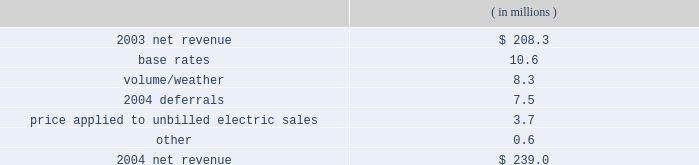Entergy new orleans , inc .
Management's financial discussion and analysis results of operations net income ( loss ) 2004 compared to 2003 net income increased $ 20.2 million primarily due to higher net revenue .
2003 compared to 2002 entergy new orleans had net income of $ 7.9 million in 2003 compared to a net loss in 2002 .
The increase was due to higher net revenue and lower interest expense , partially offset by higher other operation and maintenance expenses and depreciation and amortization expenses .
Net revenue 2004 compared to 2003 net revenue , which is entergy new orleans' measure of gross margin , consists of operating revenues net of : 1 ) fuel , fuel-related , and purchased power expenses and 2 ) other regulatory credits .
Following is an analysis of the change in net revenue comparing 2004 to 2003. .
The increase in base rates was effective june 2003 .
The rate increase is discussed in note 2 to the domestic utility companies and system energy financial statements .
The volume/weather variance is primarily due to increased billed electric usage of 162 gwh in the industrial service sector .
The increase was partially offset by milder weather in the residential and commercial sectors .
The 2004 deferrals variance is due to the deferral of voluntary severance plan and fossil plant maintenance expenses in accordance with a stipulation approved by the city council in august 2004 .
The stipulation allows for the recovery of these costs through amortization of a regulatory asset .
The voluntary severance plan and fossil plant maintenance expenses are being amortized over a five-year period that became effective january 2004 and january 2003 , respectively .
The formula rate plan is discussed in note 2 to the domestic utility companies and system energy financial statements .
The price applied to unbilled electric sales variance is due to an increase in the fuel price applied to unbilled sales. .
What is entergy's net income as a percentage of net revenue in 2003? 
Computations: (7.9 / 208.3)
Answer: 0.03793. 